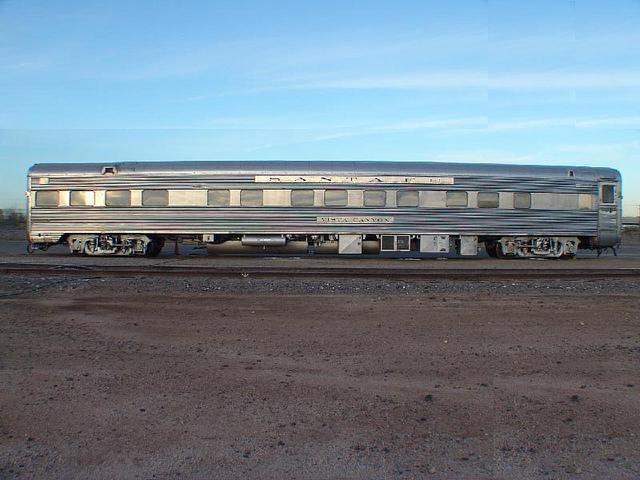Is this the train engine?
Write a very short answer. No. Is this an aerial photo?
Write a very short answer. No. What color is the ground?
Keep it brief. Brown. Is the train moving?
Answer briefly. No. Was this photo taken from inside of a vehicle?
Answer briefly. No. 